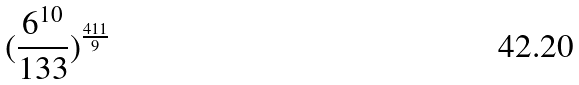<formula> <loc_0><loc_0><loc_500><loc_500>( \frac { 6 ^ { 1 0 } } { 1 3 3 } ) ^ { \frac { 4 1 1 } { 9 } }</formula> 